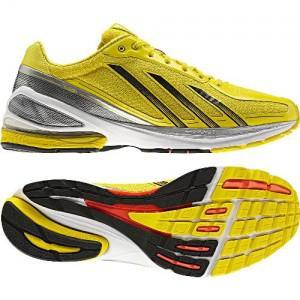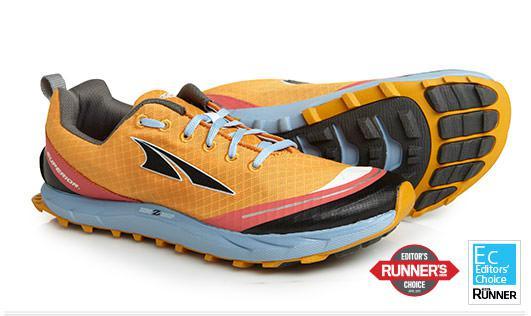The first image is the image on the left, the second image is the image on the right. Evaluate the accuracy of this statement regarding the images: "Two pairs of shoes, each laced with coordinating laces, are shown with one shoe sideways and the other shoe laying behind it with a colorful sole showing.". Is it true? Answer yes or no. No. 